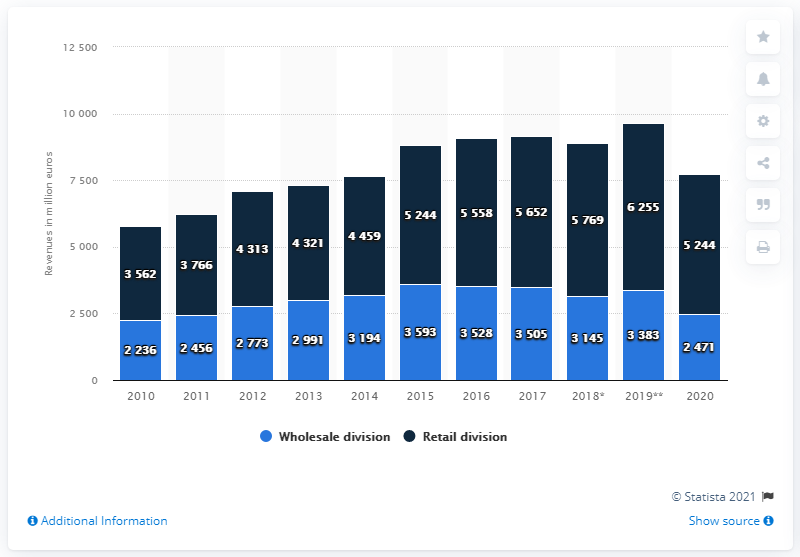Identify some key points in this picture. Luxottica's retail division achieved global net sales of 52,444 in 2020. 